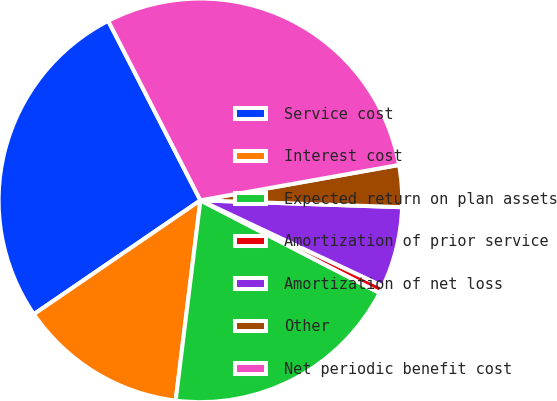Convert chart. <chart><loc_0><loc_0><loc_500><loc_500><pie_chart><fcel>Service cost<fcel>Interest cost<fcel>Expected return on plan assets<fcel>Amortization of prior service<fcel>Amortization of net loss<fcel>Other<fcel>Net periodic benefit cost<nl><fcel>27.0%<fcel>13.5%<fcel>19.37%<fcel>0.59%<fcel>6.46%<fcel>3.35%<fcel>29.75%<nl></chart> 